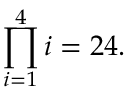<formula> <loc_0><loc_0><loc_500><loc_500>\prod _ { i = 1 } ^ { 4 } i = 2 4 .</formula> 